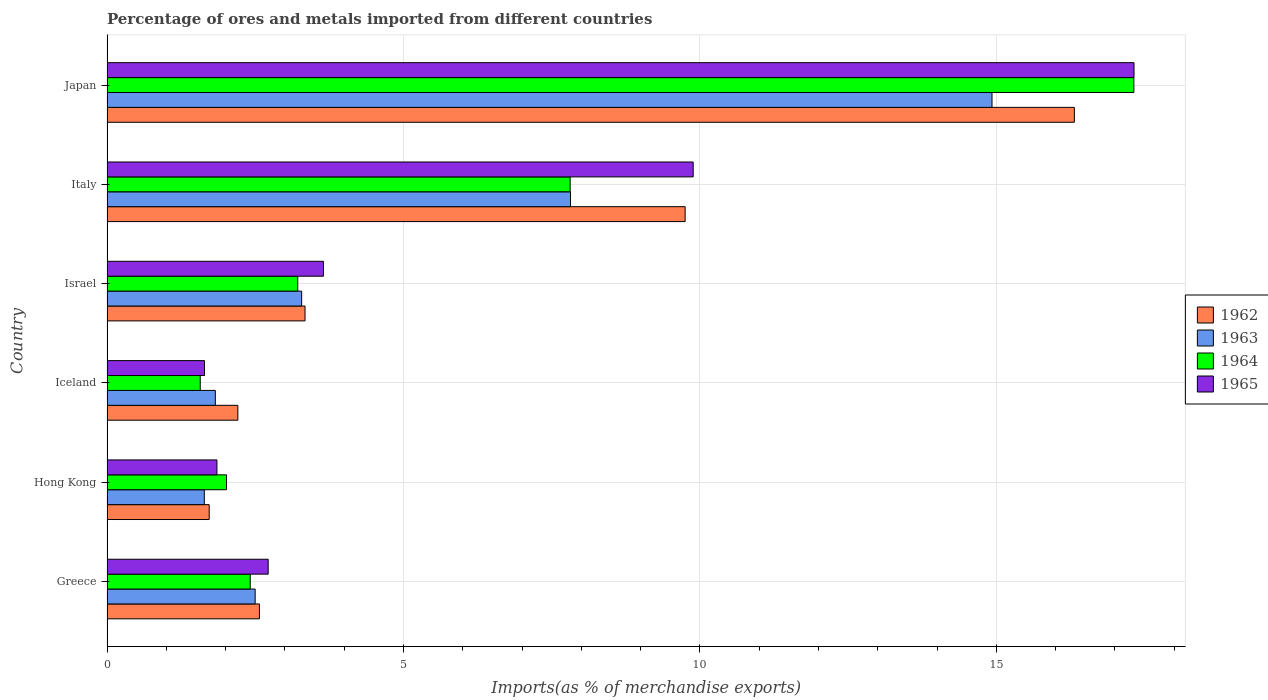Are the number of bars on each tick of the Y-axis equal?
Give a very brief answer. Yes. In how many cases, is the number of bars for a given country not equal to the number of legend labels?
Offer a very short reply. 0. What is the percentage of imports to different countries in 1963 in Iceland?
Provide a short and direct response. 1.83. Across all countries, what is the maximum percentage of imports to different countries in 1963?
Offer a very short reply. 14.93. Across all countries, what is the minimum percentage of imports to different countries in 1964?
Your response must be concise. 1.57. In which country was the percentage of imports to different countries in 1962 minimum?
Offer a terse response. Hong Kong. What is the total percentage of imports to different countries in 1965 in the graph?
Ensure brevity in your answer.  37.08. What is the difference between the percentage of imports to different countries in 1964 in Israel and that in Italy?
Your answer should be compact. -4.59. What is the difference between the percentage of imports to different countries in 1963 in Israel and the percentage of imports to different countries in 1962 in Hong Kong?
Your answer should be compact. 1.56. What is the average percentage of imports to different countries in 1963 per country?
Provide a short and direct response. 5.33. What is the difference between the percentage of imports to different countries in 1963 and percentage of imports to different countries in 1962 in Israel?
Offer a terse response. -0.06. In how many countries, is the percentage of imports to different countries in 1965 greater than 10 %?
Offer a terse response. 1. What is the ratio of the percentage of imports to different countries in 1965 in Hong Kong to that in Italy?
Offer a terse response. 0.19. Is the percentage of imports to different countries in 1963 in Iceland less than that in Israel?
Your answer should be compact. Yes. Is the difference between the percentage of imports to different countries in 1963 in Hong Kong and Italy greater than the difference between the percentage of imports to different countries in 1962 in Hong Kong and Italy?
Provide a succinct answer. Yes. What is the difference between the highest and the second highest percentage of imports to different countries in 1964?
Give a very brief answer. 9.51. What is the difference between the highest and the lowest percentage of imports to different countries in 1963?
Ensure brevity in your answer.  13.29. Is it the case that in every country, the sum of the percentage of imports to different countries in 1962 and percentage of imports to different countries in 1963 is greater than the sum of percentage of imports to different countries in 1965 and percentage of imports to different countries in 1964?
Offer a terse response. No. What does the 2nd bar from the top in Israel represents?
Give a very brief answer. 1964. What does the 1st bar from the bottom in Iceland represents?
Your answer should be compact. 1962. Is it the case that in every country, the sum of the percentage of imports to different countries in 1964 and percentage of imports to different countries in 1963 is greater than the percentage of imports to different countries in 1962?
Your response must be concise. Yes. Are the values on the major ticks of X-axis written in scientific E-notation?
Your answer should be compact. No. How are the legend labels stacked?
Give a very brief answer. Vertical. What is the title of the graph?
Offer a very short reply. Percentage of ores and metals imported from different countries. Does "1989" appear as one of the legend labels in the graph?
Keep it short and to the point. No. What is the label or title of the X-axis?
Offer a very short reply. Imports(as % of merchandise exports). What is the label or title of the Y-axis?
Your answer should be very brief. Country. What is the Imports(as % of merchandise exports) in 1962 in Greece?
Offer a terse response. 2.57. What is the Imports(as % of merchandise exports) of 1963 in Greece?
Your answer should be compact. 2.5. What is the Imports(as % of merchandise exports) in 1964 in Greece?
Give a very brief answer. 2.42. What is the Imports(as % of merchandise exports) of 1965 in Greece?
Keep it short and to the point. 2.72. What is the Imports(as % of merchandise exports) in 1962 in Hong Kong?
Keep it short and to the point. 1.72. What is the Imports(as % of merchandise exports) in 1963 in Hong Kong?
Offer a very short reply. 1.64. What is the Imports(as % of merchandise exports) in 1964 in Hong Kong?
Provide a short and direct response. 2.02. What is the Imports(as % of merchandise exports) of 1965 in Hong Kong?
Your answer should be compact. 1.85. What is the Imports(as % of merchandise exports) in 1962 in Iceland?
Make the answer very short. 2.21. What is the Imports(as % of merchandise exports) in 1963 in Iceland?
Your response must be concise. 1.83. What is the Imports(as % of merchandise exports) in 1964 in Iceland?
Provide a succinct answer. 1.57. What is the Imports(as % of merchandise exports) in 1965 in Iceland?
Give a very brief answer. 1.64. What is the Imports(as % of merchandise exports) in 1962 in Israel?
Provide a succinct answer. 3.34. What is the Imports(as % of merchandise exports) of 1963 in Israel?
Make the answer very short. 3.28. What is the Imports(as % of merchandise exports) of 1964 in Israel?
Offer a terse response. 3.22. What is the Imports(as % of merchandise exports) of 1965 in Israel?
Your answer should be compact. 3.65. What is the Imports(as % of merchandise exports) of 1962 in Italy?
Ensure brevity in your answer.  9.75. What is the Imports(as % of merchandise exports) in 1963 in Italy?
Your answer should be compact. 7.82. What is the Imports(as % of merchandise exports) of 1964 in Italy?
Provide a succinct answer. 7.81. What is the Imports(as % of merchandise exports) in 1965 in Italy?
Offer a terse response. 9.89. What is the Imports(as % of merchandise exports) of 1962 in Japan?
Provide a succinct answer. 16.32. What is the Imports(as % of merchandise exports) in 1963 in Japan?
Keep it short and to the point. 14.93. What is the Imports(as % of merchandise exports) in 1964 in Japan?
Your response must be concise. 17.32. What is the Imports(as % of merchandise exports) in 1965 in Japan?
Your answer should be compact. 17.32. Across all countries, what is the maximum Imports(as % of merchandise exports) of 1962?
Keep it short and to the point. 16.32. Across all countries, what is the maximum Imports(as % of merchandise exports) of 1963?
Your response must be concise. 14.93. Across all countries, what is the maximum Imports(as % of merchandise exports) of 1964?
Ensure brevity in your answer.  17.32. Across all countries, what is the maximum Imports(as % of merchandise exports) in 1965?
Your response must be concise. 17.32. Across all countries, what is the minimum Imports(as % of merchandise exports) in 1962?
Provide a short and direct response. 1.72. Across all countries, what is the minimum Imports(as % of merchandise exports) of 1963?
Ensure brevity in your answer.  1.64. Across all countries, what is the minimum Imports(as % of merchandise exports) of 1964?
Offer a very short reply. 1.57. Across all countries, what is the minimum Imports(as % of merchandise exports) of 1965?
Your response must be concise. 1.64. What is the total Imports(as % of merchandise exports) in 1962 in the graph?
Your answer should be compact. 35.91. What is the total Imports(as % of merchandise exports) of 1963 in the graph?
Give a very brief answer. 32. What is the total Imports(as % of merchandise exports) in 1964 in the graph?
Your response must be concise. 34.35. What is the total Imports(as % of merchandise exports) in 1965 in the graph?
Provide a succinct answer. 37.08. What is the difference between the Imports(as % of merchandise exports) of 1962 in Greece and that in Hong Kong?
Offer a very short reply. 0.85. What is the difference between the Imports(as % of merchandise exports) of 1963 in Greece and that in Hong Kong?
Ensure brevity in your answer.  0.86. What is the difference between the Imports(as % of merchandise exports) in 1964 in Greece and that in Hong Kong?
Provide a succinct answer. 0.4. What is the difference between the Imports(as % of merchandise exports) of 1965 in Greece and that in Hong Kong?
Offer a very short reply. 0.86. What is the difference between the Imports(as % of merchandise exports) of 1962 in Greece and that in Iceland?
Ensure brevity in your answer.  0.36. What is the difference between the Imports(as % of merchandise exports) of 1963 in Greece and that in Iceland?
Your answer should be very brief. 0.67. What is the difference between the Imports(as % of merchandise exports) of 1964 in Greece and that in Iceland?
Provide a succinct answer. 0.84. What is the difference between the Imports(as % of merchandise exports) of 1965 in Greece and that in Iceland?
Ensure brevity in your answer.  1.07. What is the difference between the Imports(as % of merchandise exports) in 1962 in Greece and that in Israel?
Give a very brief answer. -0.77. What is the difference between the Imports(as % of merchandise exports) of 1963 in Greece and that in Israel?
Your answer should be very brief. -0.78. What is the difference between the Imports(as % of merchandise exports) in 1964 in Greece and that in Israel?
Make the answer very short. -0.8. What is the difference between the Imports(as % of merchandise exports) in 1965 in Greece and that in Israel?
Ensure brevity in your answer.  -0.93. What is the difference between the Imports(as % of merchandise exports) in 1962 in Greece and that in Italy?
Make the answer very short. -7.18. What is the difference between the Imports(as % of merchandise exports) of 1963 in Greece and that in Italy?
Keep it short and to the point. -5.32. What is the difference between the Imports(as % of merchandise exports) in 1964 in Greece and that in Italy?
Provide a succinct answer. -5.4. What is the difference between the Imports(as % of merchandise exports) in 1965 in Greece and that in Italy?
Offer a terse response. -7.17. What is the difference between the Imports(as % of merchandise exports) of 1962 in Greece and that in Japan?
Provide a succinct answer. -13.75. What is the difference between the Imports(as % of merchandise exports) of 1963 in Greece and that in Japan?
Give a very brief answer. -12.43. What is the difference between the Imports(as % of merchandise exports) of 1964 in Greece and that in Japan?
Your response must be concise. -14.9. What is the difference between the Imports(as % of merchandise exports) in 1965 in Greece and that in Japan?
Your answer should be compact. -14.6. What is the difference between the Imports(as % of merchandise exports) in 1962 in Hong Kong and that in Iceland?
Your answer should be very brief. -0.48. What is the difference between the Imports(as % of merchandise exports) in 1963 in Hong Kong and that in Iceland?
Ensure brevity in your answer.  -0.19. What is the difference between the Imports(as % of merchandise exports) of 1964 in Hong Kong and that in Iceland?
Provide a short and direct response. 0.44. What is the difference between the Imports(as % of merchandise exports) of 1965 in Hong Kong and that in Iceland?
Ensure brevity in your answer.  0.21. What is the difference between the Imports(as % of merchandise exports) in 1962 in Hong Kong and that in Israel?
Make the answer very short. -1.62. What is the difference between the Imports(as % of merchandise exports) of 1963 in Hong Kong and that in Israel?
Provide a succinct answer. -1.64. What is the difference between the Imports(as % of merchandise exports) of 1964 in Hong Kong and that in Israel?
Provide a succinct answer. -1.2. What is the difference between the Imports(as % of merchandise exports) in 1965 in Hong Kong and that in Israel?
Provide a succinct answer. -1.8. What is the difference between the Imports(as % of merchandise exports) in 1962 in Hong Kong and that in Italy?
Your response must be concise. -8.03. What is the difference between the Imports(as % of merchandise exports) in 1963 in Hong Kong and that in Italy?
Provide a succinct answer. -6.18. What is the difference between the Imports(as % of merchandise exports) of 1964 in Hong Kong and that in Italy?
Provide a short and direct response. -5.8. What is the difference between the Imports(as % of merchandise exports) in 1965 in Hong Kong and that in Italy?
Provide a short and direct response. -8.03. What is the difference between the Imports(as % of merchandise exports) of 1962 in Hong Kong and that in Japan?
Your response must be concise. -14.59. What is the difference between the Imports(as % of merchandise exports) of 1963 in Hong Kong and that in Japan?
Your answer should be very brief. -13.29. What is the difference between the Imports(as % of merchandise exports) of 1964 in Hong Kong and that in Japan?
Make the answer very short. -15.3. What is the difference between the Imports(as % of merchandise exports) of 1965 in Hong Kong and that in Japan?
Provide a short and direct response. -15.47. What is the difference between the Imports(as % of merchandise exports) of 1962 in Iceland and that in Israel?
Keep it short and to the point. -1.13. What is the difference between the Imports(as % of merchandise exports) of 1963 in Iceland and that in Israel?
Give a very brief answer. -1.46. What is the difference between the Imports(as % of merchandise exports) of 1964 in Iceland and that in Israel?
Ensure brevity in your answer.  -1.65. What is the difference between the Imports(as % of merchandise exports) in 1965 in Iceland and that in Israel?
Offer a very short reply. -2.01. What is the difference between the Imports(as % of merchandise exports) of 1962 in Iceland and that in Italy?
Provide a short and direct response. -7.54. What is the difference between the Imports(as % of merchandise exports) of 1963 in Iceland and that in Italy?
Give a very brief answer. -5.99. What is the difference between the Imports(as % of merchandise exports) in 1964 in Iceland and that in Italy?
Provide a short and direct response. -6.24. What is the difference between the Imports(as % of merchandise exports) of 1965 in Iceland and that in Italy?
Give a very brief answer. -8.24. What is the difference between the Imports(as % of merchandise exports) of 1962 in Iceland and that in Japan?
Make the answer very short. -14.11. What is the difference between the Imports(as % of merchandise exports) in 1963 in Iceland and that in Japan?
Offer a very short reply. -13.1. What is the difference between the Imports(as % of merchandise exports) in 1964 in Iceland and that in Japan?
Your answer should be compact. -15.75. What is the difference between the Imports(as % of merchandise exports) of 1965 in Iceland and that in Japan?
Provide a succinct answer. -15.68. What is the difference between the Imports(as % of merchandise exports) of 1962 in Israel and that in Italy?
Offer a terse response. -6.41. What is the difference between the Imports(as % of merchandise exports) in 1963 in Israel and that in Italy?
Give a very brief answer. -4.53. What is the difference between the Imports(as % of merchandise exports) of 1964 in Israel and that in Italy?
Give a very brief answer. -4.59. What is the difference between the Imports(as % of merchandise exports) of 1965 in Israel and that in Italy?
Provide a short and direct response. -6.24. What is the difference between the Imports(as % of merchandise exports) of 1962 in Israel and that in Japan?
Make the answer very short. -12.98. What is the difference between the Imports(as % of merchandise exports) of 1963 in Israel and that in Japan?
Offer a very short reply. -11.64. What is the difference between the Imports(as % of merchandise exports) in 1964 in Israel and that in Japan?
Make the answer very short. -14.1. What is the difference between the Imports(as % of merchandise exports) in 1965 in Israel and that in Japan?
Your response must be concise. -13.67. What is the difference between the Imports(as % of merchandise exports) of 1962 in Italy and that in Japan?
Give a very brief answer. -6.57. What is the difference between the Imports(as % of merchandise exports) in 1963 in Italy and that in Japan?
Offer a very short reply. -7.11. What is the difference between the Imports(as % of merchandise exports) in 1964 in Italy and that in Japan?
Your answer should be compact. -9.51. What is the difference between the Imports(as % of merchandise exports) in 1965 in Italy and that in Japan?
Make the answer very short. -7.44. What is the difference between the Imports(as % of merchandise exports) of 1962 in Greece and the Imports(as % of merchandise exports) of 1963 in Hong Kong?
Make the answer very short. 0.93. What is the difference between the Imports(as % of merchandise exports) of 1962 in Greece and the Imports(as % of merchandise exports) of 1964 in Hong Kong?
Provide a short and direct response. 0.55. What is the difference between the Imports(as % of merchandise exports) in 1962 in Greece and the Imports(as % of merchandise exports) in 1965 in Hong Kong?
Keep it short and to the point. 0.72. What is the difference between the Imports(as % of merchandise exports) of 1963 in Greece and the Imports(as % of merchandise exports) of 1964 in Hong Kong?
Your answer should be compact. 0.48. What is the difference between the Imports(as % of merchandise exports) of 1963 in Greece and the Imports(as % of merchandise exports) of 1965 in Hong Kong?
Your answer should be very brief. 0.64. What is the difference between the Imports(as % of merchandise exports) in 1964 in Greece and the Imports(as % of merchandise exports) in 1965 in Hong Kong?
Make the answer very short. 0.56. What is the difference between the Imports(as % of merchandise exports) of 1962 in Greece and the Imports(as % of merchandise exports) of 1963 in Iceland?
Your answer should be very brief. 0.74. What is the difference between the Imports(as % of merchandise exports) in 1962 in Greece and the Imports(as % of merchandise exports) in 1965 in Iceland?
Provide a short and direct response. 0.93. What is the difference between the Imports(as % of merchandise exports) in 1963 in Greece and the Imports(as % of merchandise exports) in 1964 in Iceland?
Keep it short and to the point. 0.93. What is the difference between the Imports(as % of merchandise exports) in 1963 in Greece and the Imports(as % of merchandise exports) in 1965 in Iceland?
Give a very brief answer. 0.85. What is the difference between the Imports(as % of merchandise exports) of 1964 in Greece and the Imports(as % of merchandise exports) of 1965 in Iceland?
Your answer should be compact. 0.77. What is the difference between the Imports(as % of merchandise exports) of 1962 in Greece and the Imports(as % of merchandise exports) of 1963 in Israel?
Your answer should be very brief. -0.71. What is the difference between the Imports(as % of merchandise exports) in 1962 in Greece and the Imports(as % of merchandise exports) in 1964 in Israel?
Offer a terse response. -0.65. What is the difference between the Imports(as % of merchandise exports) in 1962 in Greece and the Imports(as % of merchandise exports) in 1965 in Israel?
Give a very brief answer. -1.08. What is the difference between the Imports(as % of merchandise exports) in 1963 in Greece and the Imports(as % of merchandise exports) in 1964 in Israel?
Provide a succinct answer. -0.72. What is the difference between the Imports(as % of merchandise exports) of 1963 in Greece and the Imports(as % of merchandise exports) of 1965 in Israel?
Your response must be concise. -1.15. What is the difference between the Imports(as % of merchandise exports) of 1964 in Greece and the Imports(as % of merchandise exports) of 1965 in Israel?
Offer a terse response. -1.24. What is the difference between the Imports(as % of merchandise exports) in 1962 in Greece and the Imports(as % of merchandise exports) in 1963 in Italy?
Give a very brief answer. -5.25. What is the difference between the Imports(as % of merchandise exports) in 1962 in Greece and the Imports(as % of merchandise exports) in 1964 in Italy?
Keep it short and to the point. -5.24. What is the difference between the Imports(as % of merchandise exports) of 1962 in Greece and the Imports(as % of merchandise exports) of 1965 in Italy?
Provide a succinct answer. -7.32. What is the difference between the Imports(as % of merchandise exports) in 1963 in Greece and the Imports(as % of merchandise exports) in 1964 in Italy?
Ensure brevity in your answer.  -5.31. What is the difference between the Imports(as % of merchandise exports) of 1963 in Greece and the Imports(as % of merchandise exports) of 1965 in Italy?
Your response must be concise. -7.39. What is the difference between the Imports(as % of merchandise exports) in 1964 in Greece and the Imports(as % of merchandise exports) in 1965 in Italy?
Keep it short and to the point. -7.47. What is the difference between the Imports(as % of merchandise exports) in 1962 in Greece and the Imports(as % of merchandise exports) in 1963 in Japan?
Ensure brevity in your answer.  -12.36. What is the difference between the Imports(as % of merchandise exports) of 1962 in Greece and the Imports(as % of merchandise exports) of 1964 in Japan?
Your answer should be very brief. -14.75. What is the difference between the Imports(as % of merchandise exports) in 1962 in Greece and the Imports(as % of merchandise exports) in 1965 in Japan?
Give a very brief answer. -14.75. What is the difference between the Imports(as % of merchandise exports) in 1963 in Greece and the Imports(as % of merchandise exports) in 1964 in Japan?
Offer a terse response. -14.82. What is the difference between the Imports(as % of merchandise exports) in 1963 in Greece and the Imports(as % of merchandise exports) in 1965 in Japan?
Keep it short and to the point. -14.82. What is the difference between the Imports(as % of merchandise exports) of 1964 in Greece and the Imports(as % of merchandise exports) of 1965 in Japan?
Keep it short and to the point. -14.91. What is the difference between the Imports(as % of merchandise exports) in 1962 in Hong Kong and the Imports(as % of merchandise exports) in 1963 in Iceland?
Offer a very short reply. -0.1. What is the difference between the Imports(as % of merchandise exports) of 1962 in Hong Kong and the Imports(as % of merchandise exports) of 1964 in Iceland?
Your answer should be very brief. 0.15. What is the difference between the Imports(as % of merchandise exports) of 1962 in Hong Kong and the Imports(as % of merchandise exports) of 1965 in Iceland?
Offer a terse response. 0.08. What is the difference between the Imports(as % of merchandise exports) of 1963 in Hong Kong and the Imports(as % of merchandise exports) of 1964 in Iceland?
Provide a succinct answer. 0.07. What is the difference between the Imports(as % of merchandise exports) in 1963 in Hong Kong and the Imports(as % of merchandise exports) in 1965 in Iceland?
Keep it short and to the point. -0. What is the difference between the Imports(as % of merchandise exports) in 1964 in Hong Kong and the Imports(as % of merchandise exports) in 1965 in Iceland?
Provide a succinct answer. 0.37. What is the difference between the Imports(as % of merchandise exports) of 1962 in Hong Kong and the Imports(as % of merchandise exports) of 1963 in Israel?
Give a very brief answer. -1.56. What is the difference between the Imports(as % of merchandise exports) of 1962 in Hong Kong and the Imports(as % of merchandise exports) of 1964 in Israel?
Offer a terse response. -1.49. What is the difference between the Imports(as % of merchandise exports) in 1962 in Hong Kong and the Imports(as % of merchandise exports) in 1965 in Israel?
Provide a succinct answer. -1.93. What is the difference between the Imports(as % of merchandise exports) in 1963 in Hong Kong and the Imports(as % of merchandise exports) in 1964 in Israel?
Ensure brevity in your answer.  -1.58. What is the difference between the Imports(as % of merchandise exports) in 1963 in Hong Kong and the Imports(as % of merchandise exports) in 1965 in Israel?
Give a very brief answer. -2.01. What is the difference between the Imports(as % of merchandise exports) in 1964 in Hong Kong and the Imports(as % of merchandise exports) in 1965 in Israel?
Give a very brief answer. -1.64. What is the difference between the Imports(as % of merchandise exports) of 1962 in Hong Kong and the Imports(as % of merchandise exports) of 1963 in Italy?
Ensure brevity in your answer.  -6.09. What is the difference between the Imports(as % of merchandise exports) of 1962 in Hong Kong and the Imports(as % of merchandise exports) of 1964 in Italy?
Offer a terse response. -6.09. What is the difference between the Imports(as % of merchandise exports) in 1962 in Hong Kong and the Imports(as % of merchandise exports) in 1965 in Italy?
Keep it short and to the point. -8.16. What is the difference between the Imports(as % of merchandise exports) in 1963 in Hong Kong and the Imports(as % of merchandise exports) in 1964 in Italy?
Ensure brevity in your answer.  -6.17. What is the difference between the Imports(as % of merchandise exports) of 1963 in Hong Kong and the Imports(as % of merchandise exports) of 1965 in Italy?
Keep it short and to the point. -8.25. What is the difference between the Imports(as % of merchandise exports) in 1964 in Hong Kong and the Imports(as % of merchandise exports) in 1965 in Italy?
Keep it short and to the point. -7.87. What is the difference between the Imports(as % of merchandise exports) of 1962 in Hong Kong and the Imports(as % of merchandise exports) of 1963 in Japan?
Your response must be concise. -13.2. What is the difference between the Imports(as % of merchandise exports) of 1962 in Hong Kong and the Imports(as % of merchandise exports) of 1964 in Japan?
Offer a very short reply. -15.6. What is the difference between the Imports(as % of merchandise exports) of 1962 in Hong Kong and the Imports(as % of merchandise exports) of 1965 in Japan?
Provide a succinct answer. -15.6. What is the difference between the Imports(as % of merchandise exports) of 1963 in Hong Kong and the Imports(as % of merchandise exports) of 1964 in Japan?
Your response must be concise. -15.68. What is the difference between the Imports(as % of merchandise exports) in 1963 in Hong Kong and the Imports(as % of merchandise exports) in 1965 in Japan?
Keep it short and to the point. -15.68. What is the difference between the Imports(as % of merchandise exports) in 1964 in Hong Kong and the Imports(as % of merchandise exports) in 1965 in Japan?
Provide a short and direct response. -15.31. What is the difference between the Imports(as % of merchandise exports) of 1962 in Iceland and the Imports(as % of merchandise exports) of 1963 in Israel?
Your answer should be very brief. -1.08. What is the difference between the Imports(as % of merchandise exports) of 1962 in Iceland and the Imports(as % of merchandise exports) of 1964 in Israel?
Your response must be concise. -1.01. What is the difference between the Imports(as % of merchandise exports) of 1962 in Iceland and the Imports(as % of merchandise exports) of 1965 in Israel?
Offer a terse response. -1.44. What is the difference between the Imports(as % of merchandise exports) in 1963 in Iceland and the Imports(as % of merchandise exports) in 1964 in Israel?
Provide a succinct answer. -1.39. What is the difference between the Imports(as % of merchandise exports) in 1963 in Iceland and the Imports(as % of merchandise exports) in 1965 in Israel?
Make the answer very short. -1.82. What is the difference between the Imports(as % of merchandise exports) of 1964 in Iceland and the Imports(as % of merchandise exports) of 1965 in Israel?
Give a very brief answer. -2.08. What is the difference between the Imports(as % of merchandise exports) in 1962 in Iceland and the Imports(as % of merchandise exports) in 1963 in Italy?
Make the answer very short. -5.61. What is the difference between the Imports(as % of merchandise exports) in 1962 in Iceland and the Imports(as % of merchandise exports) in 1964 in Italy?
Keep it short and to the point. -5.61. What is the difference between the Imports(as % of merchandise exports) in 1962 in Iceland and the Imports(as % of merchandise exports) in 1965 in Italy?
Ensure brevity in your answer.  -7.68. What is the difference between the Imports(as % of merchandise exports) in 1963 in Iceland and the Imports(as % of merchandise exports) in 1964 in Italy?
Make the answer very short. -5.98. What is the difference between the Imports(as % of merchandise exports) of 1963 in Iceland and the Imports(as % of merchandise exports) of 1965 in Italy?
Your response must be concise. -8.06. What is the difference between the Imports(as % of merchandise exports) of 1964 in Iceland and the Imports(as % of merchandise exports) of 1965 in Italy?
Provide a short and direct response. -8.31. What is the difference between the Imports(as % of merchandise exports) in 1962 in Iceland and the Imports(as % of merchandise exports) in 1963 in Japan?
Your response must be concise. -12.72. What is the difference between the Imports(as % of merchandise exports) in 1962 in Iceland and the Imports(as % of merchandise exports) in 1964 in Japan?
Provide a short and direct response. -15.11. What is the difference between the Imports(as % of merchandise exports) of 1962 in Iceland and the Imports(as % of merchandise exports) of 1965 in Japan?
Keep it short and to the point. -15.12. What is the difference between the Imports(as % of merchandise exports) of 1963 in Iceland and the Imports(as % of merchandise exports) of 1964 in Japan?
Your answer should be very brief. -15.49. What is the difference between the Imports(as % of merchandise exports) of 1963 in Iceland and the Imports(as % of merchandise exports) of 1965 in Japan?
Make the answer very short. -15.5. What is the difference between the Imports(as % of merchandise exports) in 1964 in Iceland and the Imports(as % of merchandise exports) in 1965 in Japan?
Provide a short and direct response. -15.75. What is the difference between the Imports(as % of merchandise exports) of 1962 in Israel and the Imports(as % of merchandise exports) of 1963 in Italy?
Give a very brief answer. -4.48. What is the difference between the Imports(as % of merchandise exports) of 1962 in Israel and the Imports(as % of merchandise exports) of 1964 in Italy?
Offer a terse response. -4.47. What is the difference between the Imports(as % of merchandise exports) of 1962 in Israel and the Imports(as % of merchandise exports) of 1965 in Italy?
Provide a succinct answer. -6.55. What is the difference between the Imports(as % of merchandise exports) in 1963 in Israel and the Imports(as % of merchandise exports) in 1964 in Italy?
Give a very brief answer. -4.53. What is the difference between the Imports(as % of merchandise exports) in 1963 in Israel and the Imports(as % of merchandise exports) in 1965 in Italy?
Provide a succinct answer. -6.6. What is the difference between the Imports(as % of merchandise exports) of 1964 in Israel and the Imports(as % of merchandise exports) of 1965 in Italy?
Make the answer very short. -6.67. What is the difference between the Imports(as % of merchandise exports) of 1962 in Israel and the Imports(as % of merchandise exports) of 1963 in Japan?
Offer a terse response. -11.59. What is the difference between the Imports(as % of merchandise exports) in 1962 in Israel and the Imports(as % of merchandise exports) in 1964 in Japan?
Offer a terse response. -13.98. What is the difference between the Imports(as % of merchandise exports) in 1962 in Israel and the Imports(as % of merchandise exports) in 1965 in Japan?
Your response must be concise. -13.98. What is the difference between the Imports(as % of merchandise exports) of 1963 in Israel and the Imports(as % of merchandise exports) of 1964 in Japan?
Offer a very short reply. -14.04. What is the difference between the Imports(as % of merchandise exports) of 1963 in Israel and the Imports(as % of merchandise exports) of 1965 in Japan?
Ensure brevity in your answer.  -14.04. What is the difference between the Imports(as % of merchandise exports) in 1964 in Israel and the Imports(as % of merchandise exports) in 1965 in Japan?
Provide a succinct answer. -14.11. What is the difference between the Imports(as % of merchandise exports) in 1962 in Italy and the Imports(as % of merchandise exports) in 1963 in Japan?
Offer a very short reply. -5.18. What is the difference between the Imports(as % of merchandise exports) in 1962 in Italy and the Imports(as % of merchandise exports) in 1964 in Japan?
Your response must be concise. -7.57. What is the difference between the Imports(as % of merchandise exports) in 1962 in Italy and the Imports(as % of merchandise exports) in 1965 in Japan?
Offer a terse response. -7.57. What is the difference between the Imports(as % of merchandise exports) in 1963 in Italy and the Imports(as % of merchandise exports) in 1964 in Japan?
Offer a terse response. -9.5. What is the difference between the Imports(as % of merchandise exports) of 1963 in Italy and the Imports(as % of merchandise exports) of 1965 in Japan?
Ensure brevity in your answer.  -9.51. What is the difference between the Imports(as % of merchandise exports) in 1964 in Italy and the Imports(as % of merchandise exports) in 1965 in Japan?
Provide a short and direct response. -9.51. What is the average Imports(as % of merchandise exports) of 1962 per country?
Offer a terse response. 5.98. What is the average Imports(as % of merchandise exports) of 1963 per country?
Offer a very short reply. 5.33. What is the average Imports(as % of merchandise exports) of 1964 per country?
Offer a terse response. 5.73. What is the average Imports(as % of merchandise exports) of 1965 per country?
Make the answer very short. 6.18. What is the difference between the Imports(as % of merchandise exports) in 1962 and Imports(as % of merchandise exports) in 1963 in Greece?
Make the answer very short. 0.07. What is the difference between the Imports(as % of merchandise exports) in 1962 and Imports(as % of merchandise exports) in 1964 in Greece?
Provide a short and direct response. 0.16. What is the difference between the Imports(as % of merchandise exports) of 1962 and Imports(as % of merchandise exports) of 1965 in Greece?
Ensure brevity in your answer.  -0.15. What is the difference between the Imports(as % of merchandise exports) in 1963 and Imports(as % of merchandise exports) in 1964 in Greece?
Your answer should be compact. 0.08. What is the difference between the Imports(as % of merchandise exports) of 1963 and Imports(as % of merchandise exports) of 1965 in Greece?
Give a very brief answer. -0.22. What is the difference between the Imports(as % of merchandise exports) of 1964 and Imports(as % of merchandise exports) of 1965 in Greece?
Offer a terse response. -0.3. What is the difference between the Imports(as % of merchandise exports) of 1962 and Imports(as % of merchandise exports) of 1963 in Hong Kong?
Your response must be concise. 0.08. What is the difference between the Imports(as % of merchandise exports) in 1962 and Imports(as % of merchandise exports) in 1964 in Hong Kong?
Provide a short and direct response. -0.29. What is the difference between the Imports(as % of merchandise exports) of 1962 and Imports(as % of merchandise exports) of 1965 in Hong Kong?
Provide a succinct answer. -0.13. What is the difference between the Imports(as % of merchandise exports) in 1963 and Imports(as % of merchandise exports) in 1964 in Hong Kong?
Provide a short and direct response. -0.37. What is the difference between the Imports(as % of merchandise exports) in 1963 and Imports(as % of merchandise exports) in 1965 in Hong Kong?
Your answer should be very brief. -0.21. What is the difference between the Imports(as % of merchandise exports) of 1964 and Imports(as % of merchandise exports) of 1965 in Hong Kong?
Offer a terse response. 0.16. What is the difference between the Imports(as % of merchandise exports) in 1962 and Imports(as % of merchandise exports) in 1963 in Iceland?
Your response must be concise. 0.38. What is the difference between the Imports(as % of merchandise exports) in 1962 and Imports(as % of merchandise exports) in 1964 in Iceland?
Make the answer very short. 0.63. What is the difference between the Imports(as % of merchandise exports) of 1962 and Imports(as % of merchandise exports) of 1965 in Iceland?
Your answer should be very brief. 0.56. What is the difference between the Imports(as % of merchandise exports) of 1963 and Imports(as % of merchandise exports) of 1964 in Iceland?
Your answer should be very brief. 0.25. What is the difference between the Imports(as % of merchandise exports) of 1963 and Imports(as % of merchandise exports) of 1965 in Iceland?
Offer a very short reply. 0.18. What is the difference between the Imports(as % of merchandise exports) in 1964 and Imports(as % of merchandise exports) in 1965 in Iceland?
Your answer should be very brief. -0.07. What is the difference between the Imports(as % of merchandise exports) of 1962 and Imports(as % of merchandise exports) of 1963 in Israel?
Your response must be concise. 0.06. What is the difference between the Imports(as % of merchandise exports) in 1962 and Imports(as % of merchandise exports) in 1964 in Israel?
Your answer should be compact. 0.12. What is the difference between the Imports(as % of merchandise exports) of 1962 and Imports(as % of merchandise exports) of 1965 in Israel?
Provide a short and direct response. -0.31. What is the difference between the Imports(as % of merchandise exports) of 1963 and Imports(as % of merchandise exports) of 1964 in Israel?
Your answer should be very brief. 0.07. What is the difference between the Imports(as % of merchandise exports) in 1963 and Imports(as % of merchandise exports) in 1965 in Israel?
Offer a very short reply. -0.37. What is the difference between the Imports(as % of merchandise exports) in 1964 and Imports(as % of merchandise exports) in 1965 in Israel?
Offer a very short reply. -0.43. What is the difference between the Imports(as % of merchandise exports) of 1962 and Imports(as % of merchandise exports) of 1963 in Italy?
Provide a succinct answer. 1.93. What is the difference between the Imports(as % of merchandise exports) of 1962 and Imports(as % of merchandise exports) of 1964 in Italy?
Offer a terse response. 1.94. What is the difference between the Imports(as % of merchandise exports) in 1962 and Imports(as % of merchandise exports) in 1965 in Italy?
Your response must be concise. -0.14. What is the difference between the Imports(as % of merchandise exports) of 1963 and Imports(as % of merchandise exports) of 1964 in Italy?
Keep it short and to the point. 0.01. What is the difference between the Imports(as % of merchandise exports) of 1963 and Imports(as % of merchandise exports) of 1965 in Italy?
Your answer should be compact. -2.07. What is the difference between the Imports(as % of merchandise exports) of 1964 and Imports(as % of merchandise exports) of 1965 in Italy?
Make the answer very short. -2.08. What is the difference between the Imports(as % of merchandise exports) of 1962 and Imports(as % of merchandise exports) of 1963 in Japan?
Keep it short and to the point. 1.39. What is the difference between the Imports(as % of merchandise exports) in 1962 and Imports(as % of merchandise exports) in 1964 in Japan?
Your response must be concise. -1. What is the difference between the Imports(as % of merchandise exports) in 1962 and Imports(as % of merchandise exports) in 1965 in Japan?
Provide a succinct answer. -1.01. What is the difference between the Imports(as % of merchandise exports) in 1963 and Imports(as % of merchandise exports) in 1964 in Japan?
Provide a succinct answer. -2.39. What is the difference between the Imports(as % of merchandise exports) of 1963 and Imports(as % of merchandise exports) of 1965 in Japan?
Make the answer very short. -2.4. What is the difference between the Imports(as % of merchandise exports) of 1964 and Imports(as % of merchandise exports) of 1965 in Japan?
Make the answer very short. -0. What is the ratio of the Imports(as % of merchandise exports) in 1962 in Greece to that in Hong Kong?
Your response must be concise. 1.49. What is the ratio of the Imports(as % of merchandise exports) of 1963 in Greece to that in Hong Kong?
Keep it short and to the point. 1.52. What is the ratio of the Imports(as % of merchandise exports) of 1964 in Greece to that in Hong Kong?
Provide a succinct answer. 1.2. What is the ratio of the Imports(as % of merchandise exports) in 1965 in Greece to that in Hong Kong?
Make the answer very short. 1.47. What is the ratio of the Imports(as % of merchandise exports) in 1962 in Greece to that in Iceland?
Provide a short and direct response. 1.16. What is the ratio of the Imports(as % of merchandise exports) of 1963 in Greece to that in Iceland?
Offer a very short reply. 1.37. What is the ratio of the Imports(as % of merchandise exports) in 1964 in Greece to that in Iceland?
Provide a succinct answer. 1.54. What is the ratio of the Imports(as % of merchandise exports) in 1965 in Greece to that in Iceland?
Your answer should be very brief. 1.65. What is the ratio of the Imports(as % of merchandise exports) of 1962 in Greece to that in Israel?
Provide a succinct answer. 0.77. What is the ratio of the Imports(as % of merchandise exports) of 1963 in Greece to that in Israel?
Provide a succinct answer. 0.76. What is the ratio of the Imports(as % of merchandise exports) in 1964 in Greece to that in Israel?
Make the answer very short. 0.75. What is the ratio of the Imports(as % of merchandise exports) of 1965 in Greece to that in Israel?
Your answer should be very brief. 0.74. What is the ratio of the Imports(as % of merchandise exports) of 1962 in Greece to that in Italy?
Make the answer very short. 0.26. What is the ratio of the Imports(as % of merchandise exports) of 1963 in Greece to that in Italy?
Make the answer very short. 0.32. What is the ratio of the Imports(as % of merchandise exports) in 1964 in Greece to that in Italy?
Your response must be concise. 0.31. What is the ratio of the Imports(as % of merchandise exports) of 1965 in Greece to that in Italy?
Provide a succinct answer. 0.28. What is the ratio of the Imports(as % of merchandise exports) of 1962 in Greece to that in Japan?
Your answer should be compact. 0.16. What is the ratio of the Imports(as % of merchandise exports) of 1963 in Greece to that in Japan?
Offer a terse response. 0.17. What is the ratio of the Imports(as % of merchandise exports) in 1964 in Greece to that in Japan?
Your answer should be compact. 0.14. What is the ratio of the Imports(as % of merchandise exports) of 1965 in Greece to that in Japan?
Provide a succinct answer. 0.16. What is the ratio of the Imports(as % of merchandise exports) in 1962 in Hong Kong to that in Iceland?
Provide a succinct answer. 0.78. What is the ratio of the Imports(as % of merchandise exports) in 1963 in Hong Kong to that in Iceland?
Your answer should be compact. 0.9. What is the ratio of the Imports(as % of merchandise exports) of 1964 in Hong Kong to that in Iceland?
Provide a succinct answer. 1.28. What is the ratio of the Imports(as % of merchandise exports) in 1965 in Hong Kong to that in Iceland?
Ensure brevity in your answer.  1.13. What is the ratio of the Imports(as % of merchandise exports) of 1962 in Hong Kong to that in Israel?
Give a very brief answer. 0.52. What is the ratio of the Imports(as % of merchandise exports) in 1963 in Hong Kong to that in Israel?
Offer a terse response. 0.5. What is the ratio of the Imports(as % of merchandise exports) in 1964 in Hong Kong to that in Israel?
Provide a short and direct response. 0.63. What is the ratio of the Imports(as % of merchandise exports) of 1965 in Hong Kong to that in Israel?
Your answer should be compact. 0.51. What is the ratio of the Imports(as % of merchandise exports) in 1962 in Hong Kong to that in Italy?
Your answer should be compact. 0.18. What is the ratio of the Imports(as % of merchandise exports) of 1963 in Hong Kong to that in Italy?
Make the answer very short. 0.21. What is the ratio of the Imports(as % of merchandise exports) of 1964 in Hong Kong to that in Italy?
Give a very brief answer. 0.26. What is the ratio of the Imports(as % of merchandise exports) of 1965 in Hong Kong to that in Italy?
Make the answer very short. 0.19. What is the ratio of the Imports(as % of merchandise exports) in 1962 in Hong Kong to that in Japan?
Offer a very short reply. 0.11. What is the ratio of the Imports(as % of merchandise exports) in 1963 in Hong Kong to that in Japan?
Your answer should be very brief. 0.11. What is the ratio of the Imports(as % of merchandise exports) of 1964 in Hong Kong to that in Japan?
Make the answer very short. 0.12. What is the ratio of the Imports(as % of merchandise exports) in 1965 in Hong Kong to that in Japan?
Ensure brevity in your answer.  0.11. What is the ratio of the Imports(as % of merchandise exports) in 1962 in Iceland to that in Israel?
Your response must be concise. 0.66. What is the ratio of the Imports(as % of merchandise exports) in 1963 in Iceland to that in Israel?
Your response must be concise. 0.56. What is the ratio of the Imports(as % of merchandise exports) of 1964 in Iceland to that in Israel?
Give a very brief answer. 0.49. What is the ratio of the Imports(as % of merchandise exports) of 1965 in Iceland to that in Israel?
Your response must be concise. 0.45. What is the ratio of the Imports(as % of merchandise exports) of 1962 in Iceland to that in Italy?
Offer a very short reply. 0.23. What is the ratio of the Imports(as % of merchandise exports) in 1963 in Iceland to that in Italy?
Give a very brief answer. 0.23. What is the ratio of the Imports(as % of merchandise exports) of 1964 in Iceland to that in Italy?
Make the answer very short. 0.2. What is the ratio of the Imports(as % of merchandise exports) of 1965 in Iceland to that in Italy?
Offer a very short reply. 0.17. What is the ratio of the Imports(as % of merchandise exports) of 1962 in Iceland to that in Japan?
Keep it short and to the point. 0.14. What is the ratio of the Imports(as % of merchandise exports) of 1963 in Iceland to that in Japan?
Make the answer very short. 0.12. What is the ratio of the Imports(as % of merchandise exports) in 1964 in Iceland to that in Japan?
Your answer should be very brief. 0.09. What is the ratio of the Imports(as % of merchandise exports) in 1965 in Iceland to that in Japan?
Your response must be concise. 0.09. What is the ratio of the Imports(as % of merchandise exports) in 1962 in Israel to that in Italy?
Your response must be concise. 0.34. What is the ratio of the Imports(as % of merchandise exports) in 1963 in Israel to that in Italy?
Provide a succinct answer. 0.42. What is the ratio of the Imports(as % of merchandise exports) in 1964 in Israel to that in Italy?
Your answer should be compact. 0.41. What is the ratio of the Imports(as % of merchandise exports) in 1965 in Israel to that in Italy?
Ensure brevity in your answer.  0.37. What is the ratio of the Imports(as % of merchandise exports) of 1962 in Israel to that in Japan?
Your answer should be very brief. 0.2. What is the ratio of the Imports(as % of merchandise exports) of 1963 in Israel to that in Japan?
Your answer should be compact. 0.22. What is the ratio of the Imports(as % of merchandise exports) in 1964 in Israel to that in Japan?
Your answer should be very brief. 0.19. What is the ratio of the Imports(as % of merchandise exports) of 1965 in Israel to that in Japan?
Your answer should be compact. 0.21. What is the ratio of the Imports(as % of merchandise exports) in 1962 in Italy to that in Japan?
Keep it short and to the point. 0.6. What is the ratio of the Imports(as % of merchandise exports) of 1963 in Italy to that in Japan?
Ensure brevity in your answer.  0.52. What is the ratio of the Imports(as % of merchandise exports) in 1964 in Italy to that in Japan?
Provide a succinct answer. 0.45. What is the ratio of the Imports(as % of merchandise exports) in 1965 in Italy to that in Japan?
Ensure brevity in your answer.  0.57. What is the difference between the highest and the second highest Imports(as % of merchandise exports) in 1962?
Your answer should be compact. 6.57. What is the difference between the highest and the second highest Imports(as % of merchandise exports) in 1963?
Offer a very short reply. 7.11. What is the difference between the highest and the second highest Imports(as % of merchandise exports) in 1964?
Offer a very short reply. 9.51. What is the difference between the highest and the second highest Imports(as % of merchandise exports) in 1965?
Give a very brief answer. 7.44. What is the difference between the highest and the lowest Imports(as % of merchandise exports) of 1962?
Keep it short and to the point. 14.59. What is the difference between the highest and the lowest Imports(as % of merchandise exports) in 1963?
Keep it short and to the point. 13.29. What is the difference between the highest and the lowest Imports(as % of merchandise exports) of 1964?
Offer a very short reply. 15.75. What is the difference between the highest and the lowest Imports(as % of merchandise exports) in 1965?
Keep it short and to the point. 15.68. 